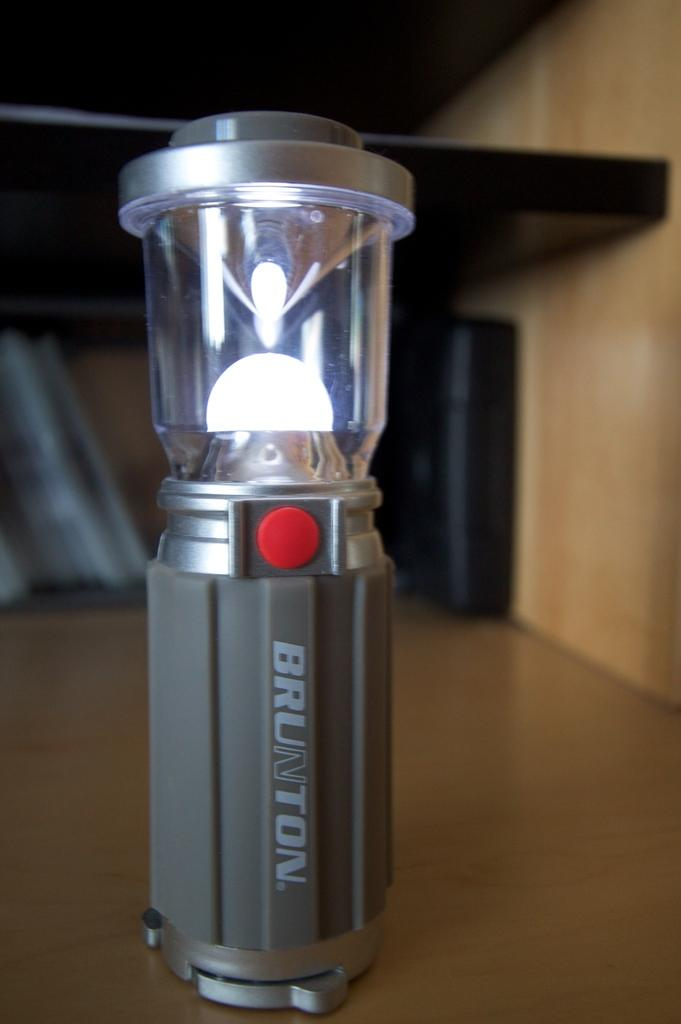Provide a one-sentence caption for the provided image. Brunton light that is gray and silver with a red button. 